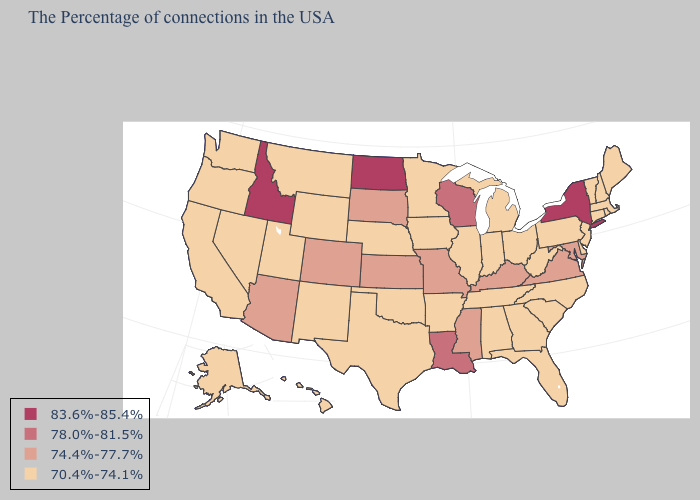How many symbols are there in the legend?
Write a very short answer. 4. Does the map have missing data?
Concise answer only. No. What is the value of New York?
Answer briefly. 83.6%-85.4%. Name the states that have a value in the range 70.4%-74.1%?
Short answer required. Maine, Massachusetts, Rhode Island, New Hampshire, Vermont, Connecticut, New Jersey, Delaware, Pennsylvania, North Carolina, South Carolina, West Virginia, Ohio, Florida, Georgia, Michigan, Indiana, Alabama, Tennessee, Illinois, Arkansas, Minnesota, Iowa, Nebraska, Oklahoma, Texas, Wyoming, New Mexico, Utah, Montana, Nevada, California, Washington, Oregon, Alaska, Hawaii. Name the states that have a value in the range 74.4%-77.7%?
Keep it brief. Maryland, Virginia, Kentucky, Mississippi, Missouri, Kansas, South Dakota, Colorado, Arizona. What is the lowest value in states that border Oregon?
Concise answer only. 70.4%-74.1%. What is the value of Arkansas?
Be succinct. 70.4%-74.1%. What is the highest value in states that border Washington?
Short answer required. 83.6%-85.4%. Name the states that have a value in the range 78.0%-81.5%?
Be succinct. Wisconsin, Louisiana. What is the highest value in the Northeast ?
Concise answer only. 83.6%-85.4%. Does California have the highest value in the West?
Answer briefly. No. How many symbols are there in the legend?
Write a very short answer. 4. Does the map have missing data?
Short answer required. No. Name the states that have a value in the range 83.6%-85.4%?
Write a very short answer. New York, North Dakota, Idaho. What is the lowest value in states that border Delaware?
Concise answer only. 70.4%-74.1%. 